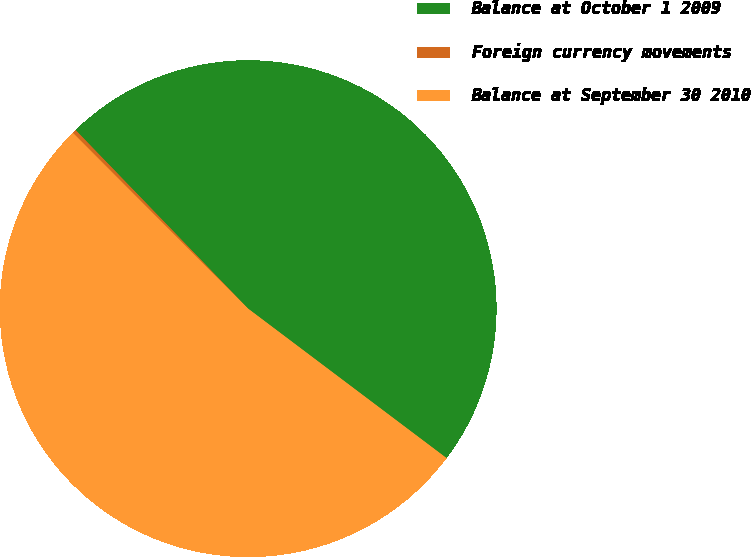Convert chart to OTSL. <chart><loc_0><loc_0><loc_500><loc_500><pie_chart><fcel>Balance at October 1 2009<fcel>Foreign currency movements<fcel>Balance at September 30 2010<nl><fcel>47.5%<fcel>0.25%<fcel>52.25%<nl></chart> 